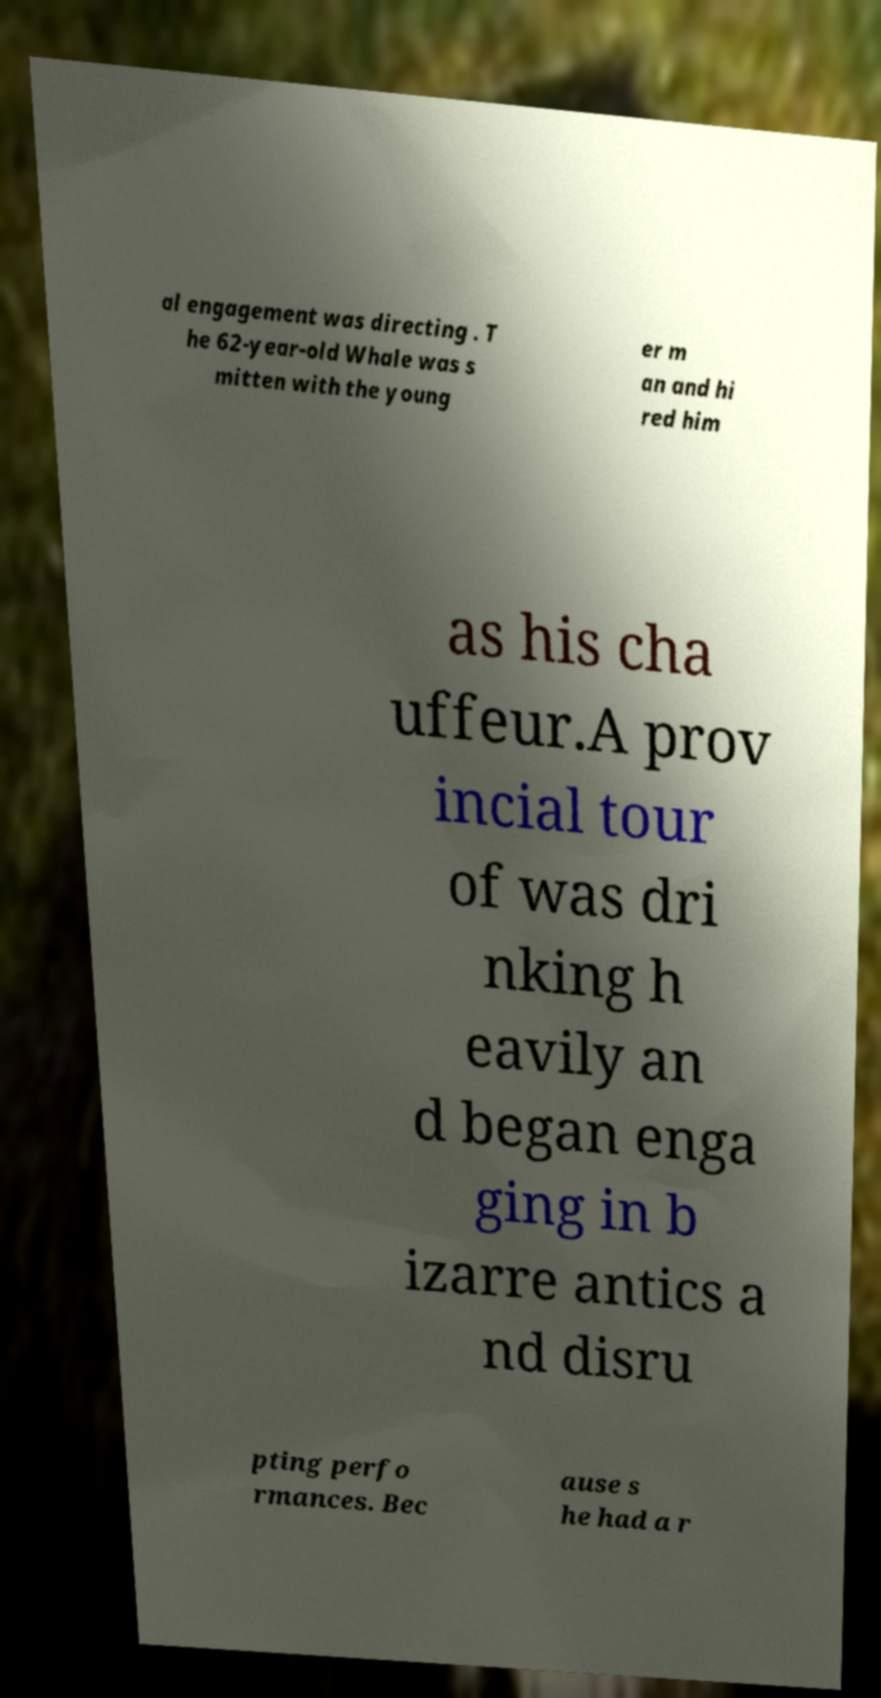Please identify and transcribe the text found in this image. al engagement was directing . T he 62-year-old Whale was s mitten with the young er m an and hi red him as his cha uffeur.A prov incial tour of was dri nking h eavily an d began enga ging in b izarre antics a nd disru pting perfo rmances. Bec ause s he had a r 